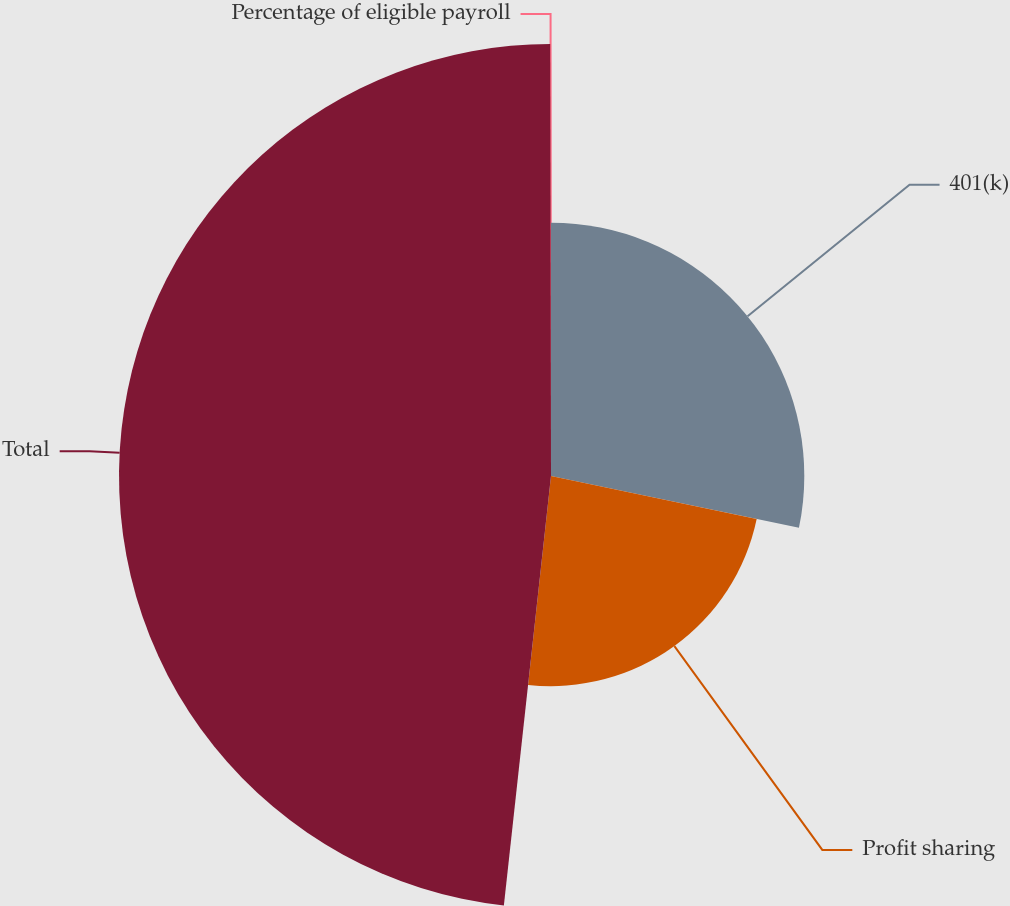<chart> <loc_0><loc_0><loc_500><loc_500><pie_chart><fcel>401(k)<fcel>Profit sharing<fcel>Total<fcel>Percentage of eligible payroll<nl><fcel>28.28%<fcel>23.46%<fcel>48.23%<fcel>0.03%<nl></chart> 